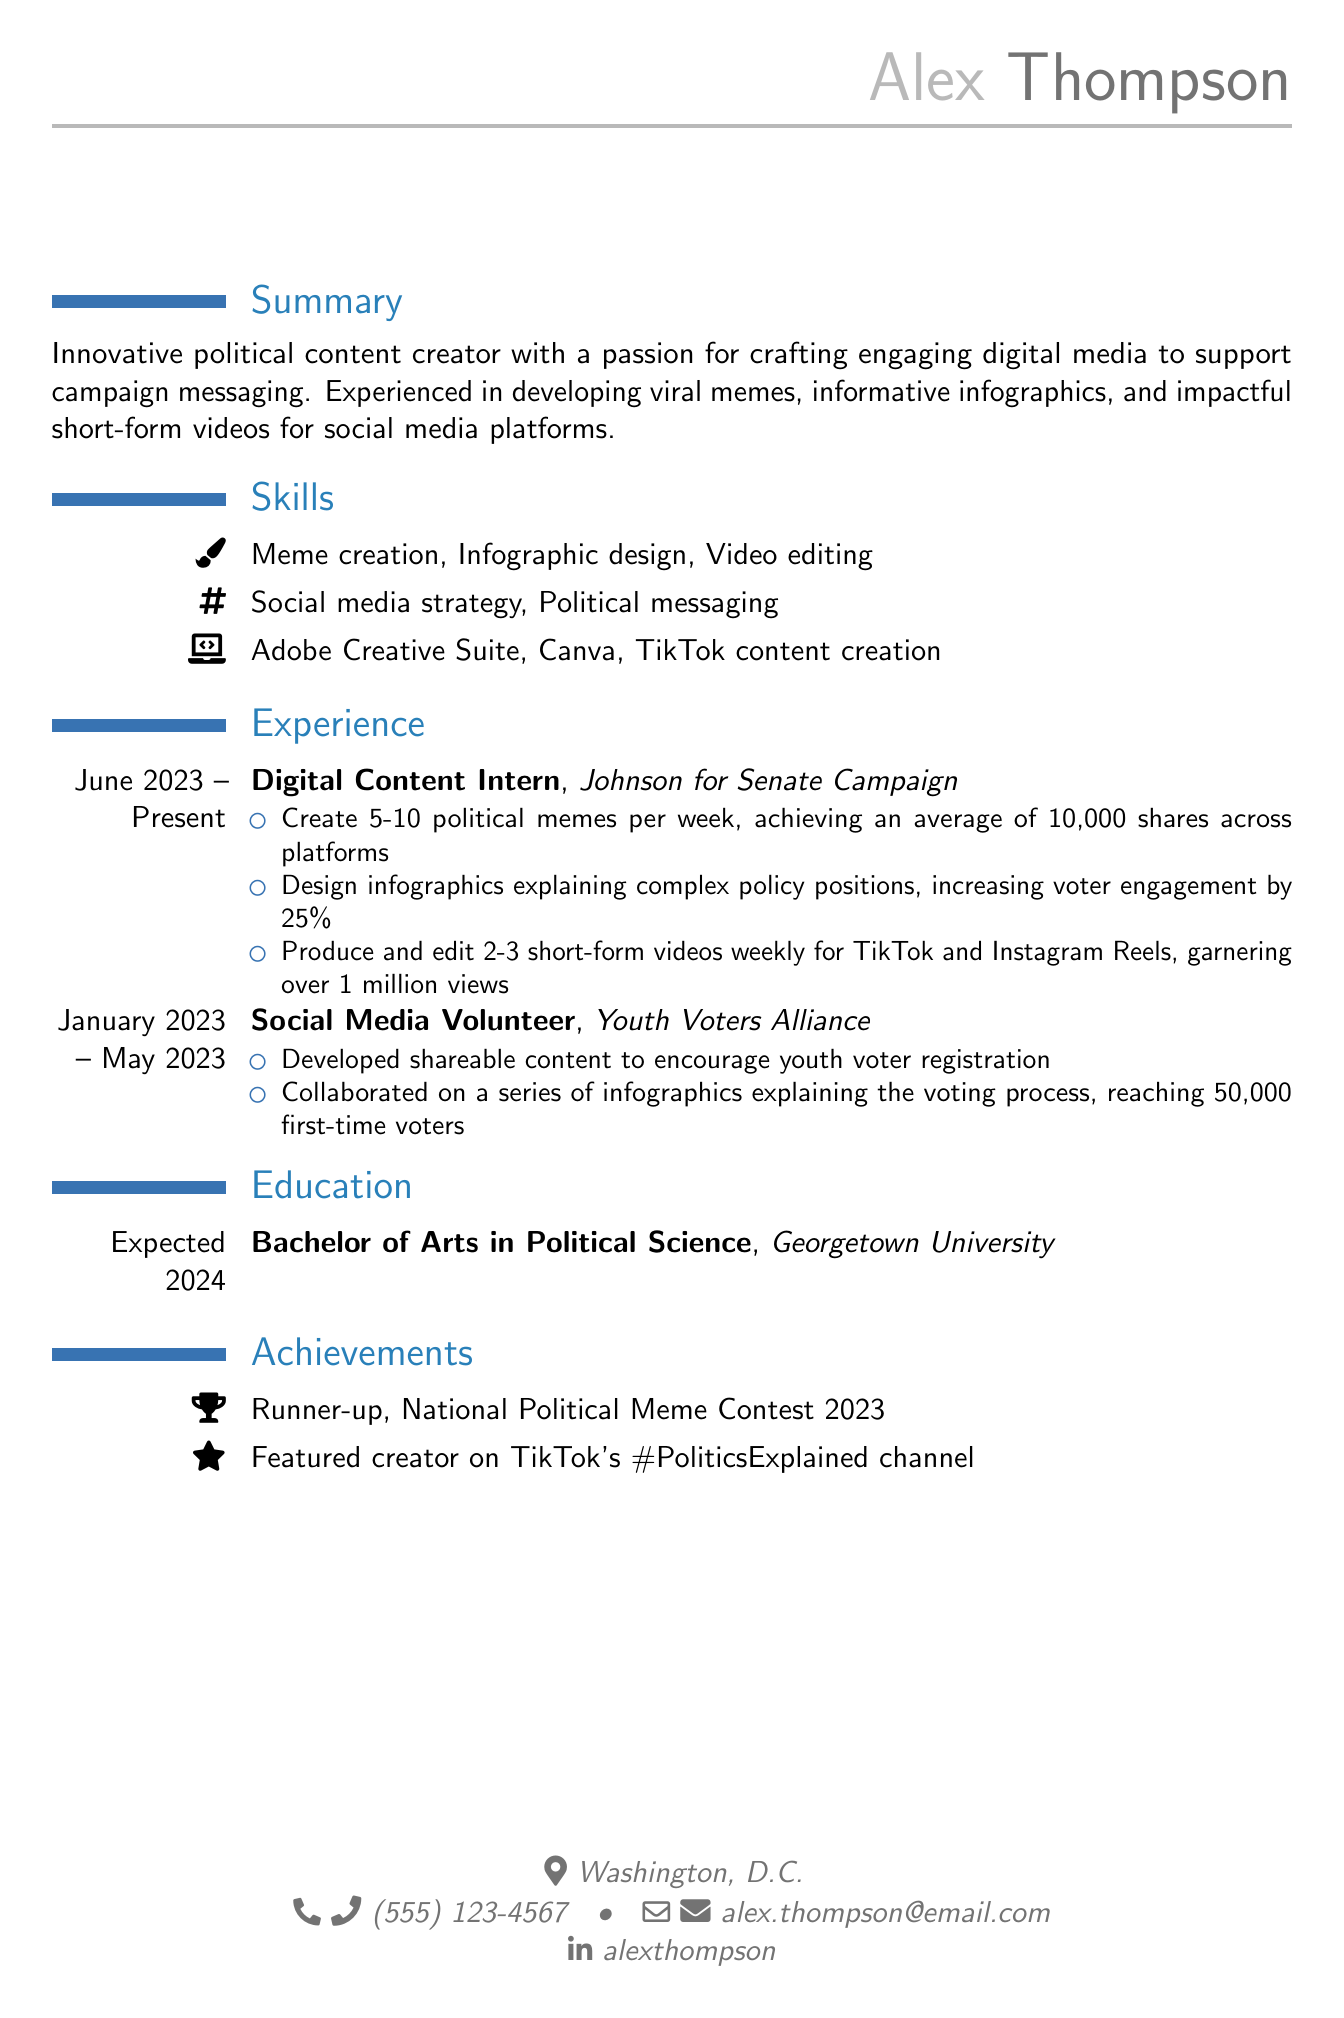What is the name of the candidate? The candidate's name is presented prominently at the top of the document.
Answer: Alex Thompson What is the email address listed on the resume? The email address is included in the personal information section.
Answer: alex.thompson@email.com How many memes does Alex create per week? The number of memes is specified in the experience section for the current intern position.
Answer: 5-10 What was the increase in voter engagement due to the infographics? The increase in engagement is mentioned in the responsibilities for the current internship.
Answer: 25% What is the expected graduation year? The expected graduation year is stated in the education section.
Answer: 2024 Which campaign did Alex work with as a Digital Content Intern? The organization where Alex interned is listed under the experience section.
Answer: Johnson for Senate Campaign How many views did the short-form videos achieve? The view count for the videos is noted in the responsibilities of the current internship.
Answer: over 1 million views What achievement is mentioned related to a meme contest? The achievement section includes notable accomplishments in competitions.
Answer: Runner-up, National Political Meme Contest 2023 How many first-time voters did the infographics reach? The reach of the infographics is described in the responsibilities of a previous volunteer role.
Answer: 50,000 first-time voters 